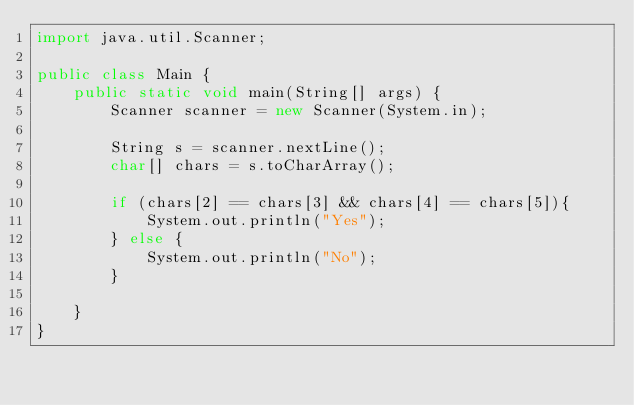Convert code to text. <code><loc_0><loc_0><loc_500><loc_500><_Java_>import java.util.Scanner;

public class Main {
    public static void main(String[] args) {
        Scanner scanner = new Scanner(System.in);

        String s = scanner.nextLine();
        char[] chars = s.toCharArray();

        if (chars[2] == chars[3] && chars[4] == chars[5]){
            System.out.println("Yes");
        } else {
            System.out.println("No");
        }

    }
}</code> 